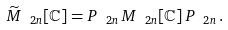Convert formula to latex. <formula><loc_0><loc_0><loc_500><loc_500>\widetilde { M } _ { \ 2 n } [ \mathbb { C } ] = P _ { \ 2 n } \, M _ { \ 2 n } [ \mathbb { C } ] \, P _ { \ 2 n } \, .</formula> 